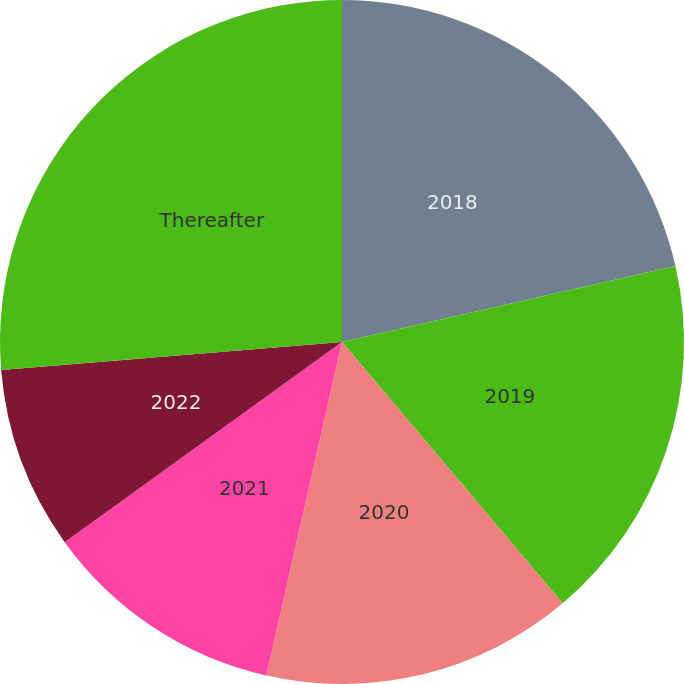Convert chart to OTSL. <chart><loc_0><loc_0><loc_500><loc_500><pie_chart><fcel>2018<fcel>2019<fcel>2020<fcel>2021<fcel>2022<fcel>Thereafter<nl><fcel>21.43%<fcel>17.41%<fcel>14.71%<fcel>11.5%<fcel>8.64%<fcel>26.31%<nl></chart> 